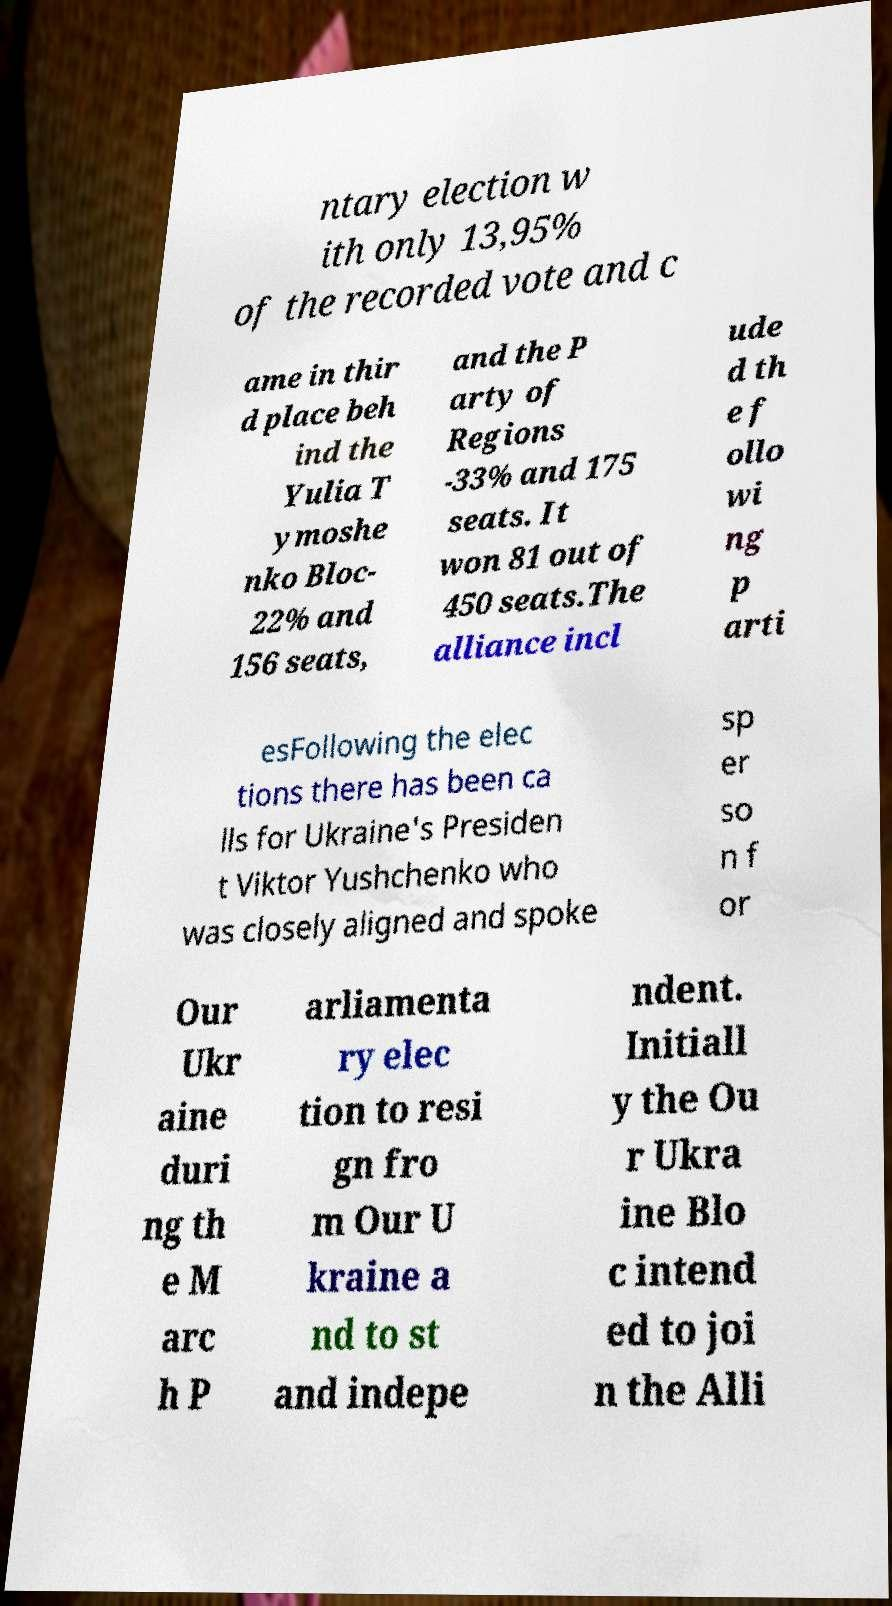For documentation purposes, I need the text within this image transcribed. Could you provide that? ntary election w ith only 13,95% of the recorded vote and c ame in thir d place beh ind the Yulia T ymoshe nko Bloc- 22% and 156 seats, and the P arty of Regions -33% and 175 seats. It won 81 out of 450 seats.The alliance incl ude d th e f ollo wi ng p arti esFollowing the elec tions there has been ca lls for Ukraine's Presiden t Viktor Yushchenko who was closely aligned and spoke sp er so n f or Our Ukr aine duri ng th e M arc h P arliamenta ry elec tion to resi gn fro m Our U kraine a nd to st and indepe ndent. Initiall y the Ou r Ukra ine Blo c intend ed to joi n the Alli 